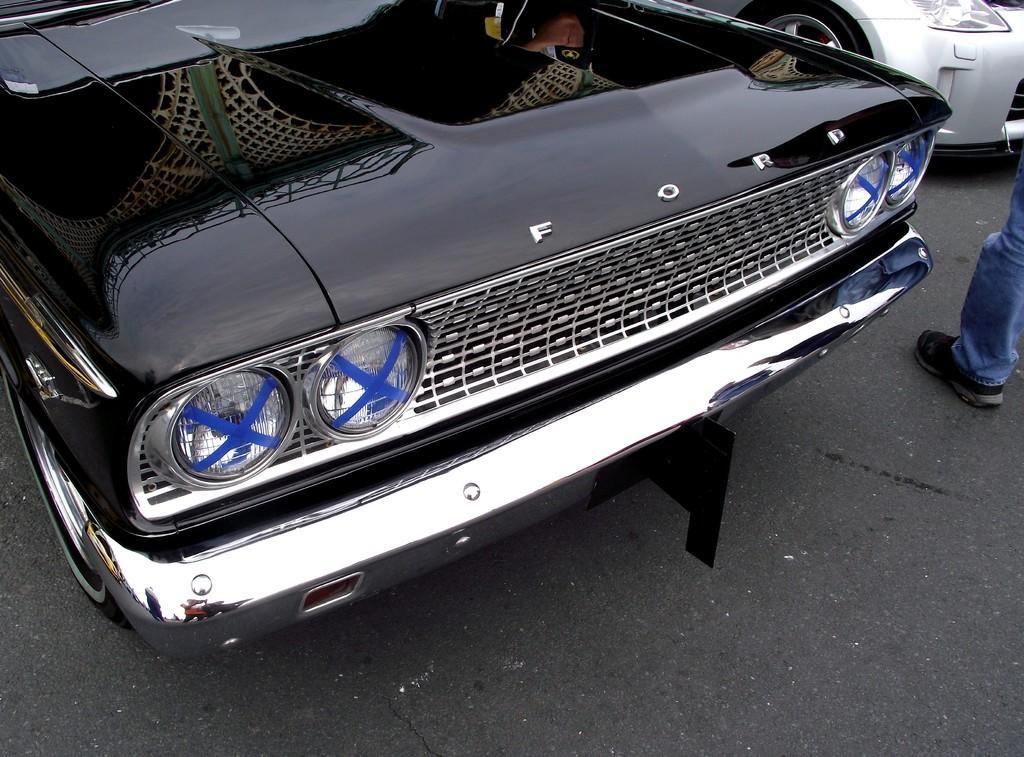Could you give a brief overview of what you see in this image? At the bottom of the image there is a road. In the center we can see cars on the road. On the right we can see a person's leg. 